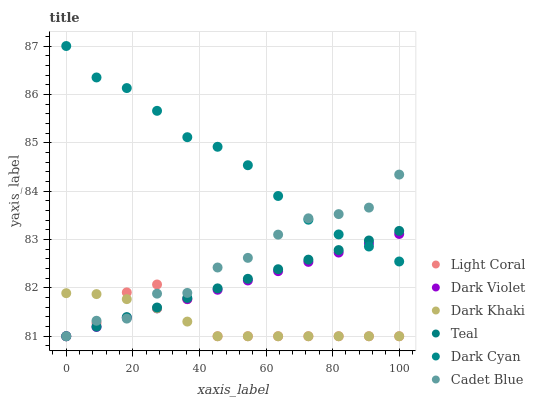Does Dark Khaki have the minimum area under the curve?
Answer yes or no. Yes. Does Dark Cyan have the maximum area under the curve?
Answer yes or no. Yes. Does Cadet Blue have the minimum area under the curve?
Answer yes or no. No. Does Cadet Blue have the maximum area under the curve?
Answer yes or no. No. Is Teal the smoothest?
Answer yes or no. Yes. Is Cadet Blue the roughest?
Answer yes or no. Yes. Is Dark Violet the smoothest?
Answer yes or no. No. Is Dark Violet the roughest?
Answer yes or no. No. Does Dark Khaki have the lowest value?
Answer yes or no. Yes. Does Dark Cyan have the lowest value?
Answer yes or no. No. Does Dark Cyan have the highest value?
Answer yes or no. Yes. Does Cadet Blue have the highest value?
Answer yes or no. No. Is Light Coral less than Dark Cyan?
Answer yes or no. Yes. Is Dark Cyan greater than Light Coral?
Answer yes or no. Yes. Does Teal intersect Dark Violet?
Answer yes or no. Yes. Is Teal less than Dark Violet?
Answer yes or no. No. Is Teal greater than Dark Violet?
Answer yes or no. No. Does Light Coral intersect Dark Cyan?
Answer yes or no. No. 